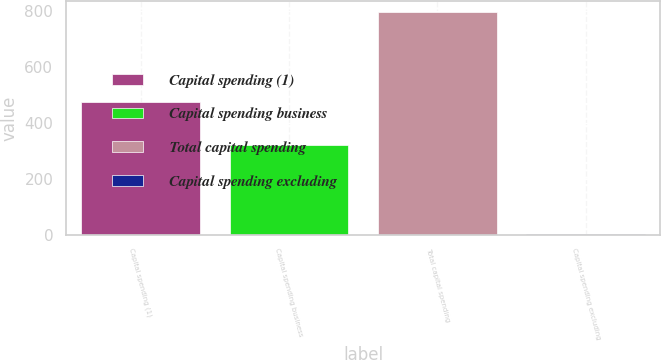<chart> <loc_0><loc_0><loc_500><loc_500><bar_chart><fcel>Capital spending (1)<fcel>Capital spending business<fcel>Total capital spending<fcel>Capital spending excluding<nl><fcel>476<fcel>320<fcel>796<fcel>3.1<nl></chart> 